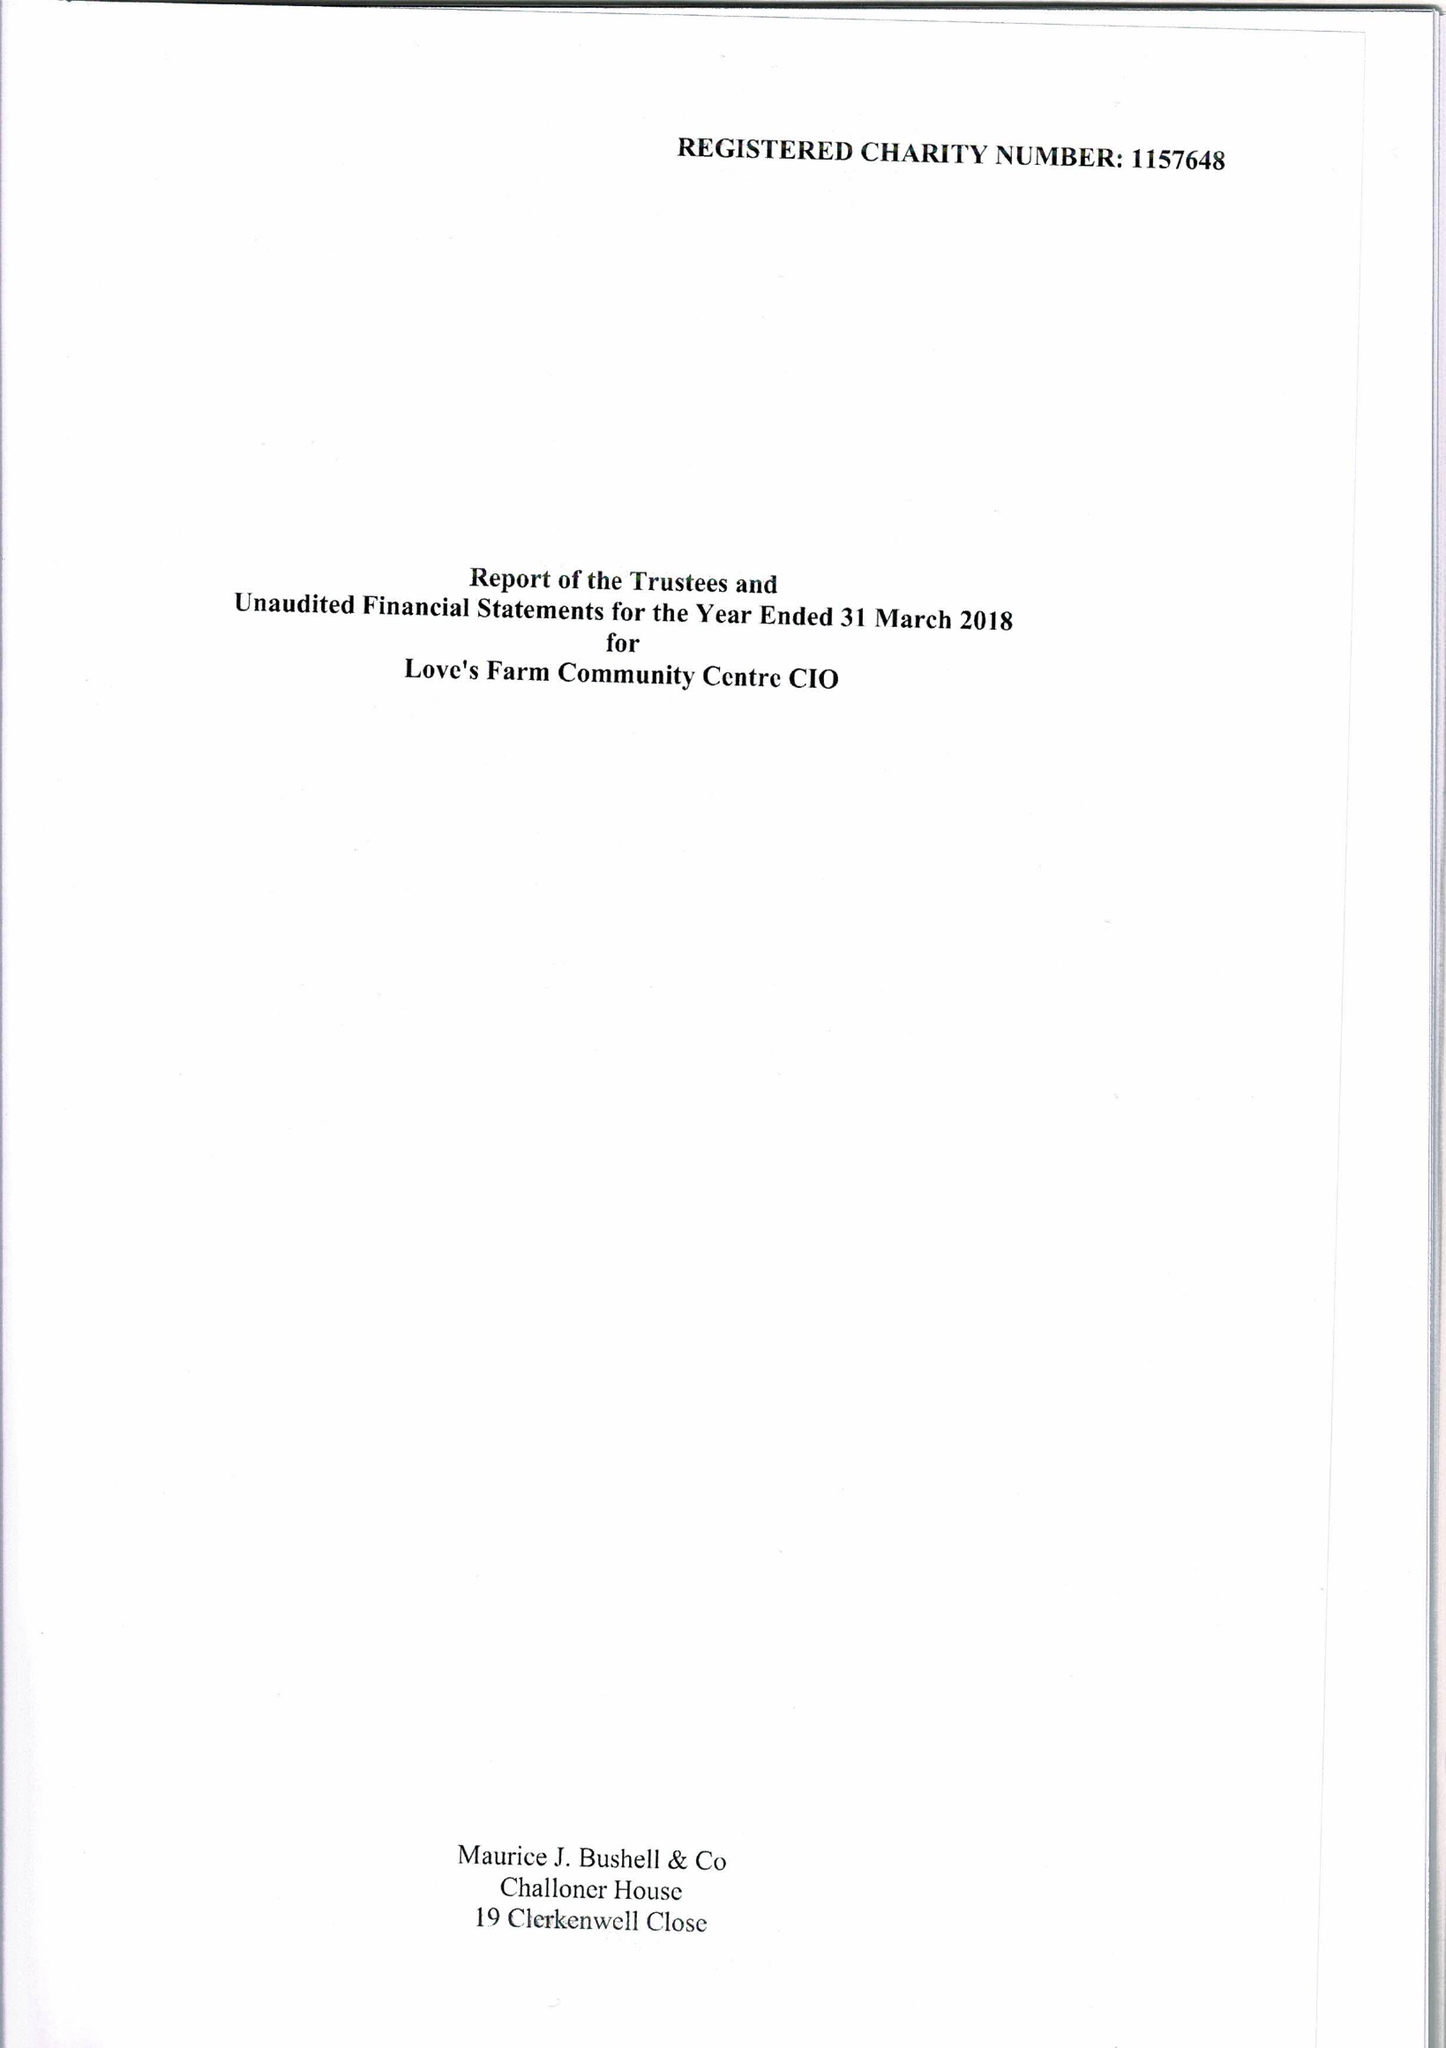What is the value for the charity_number?
Answer the question using a single word or phrase. 1157648 